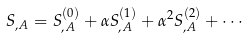Convert formula to latex. <formula><loc_0><loc_0><loc_500><loc_500>S _ { , A } = S _ { , A } ^ { ( 0 ) } + \alpha S _ { , A } ^ { ( 1 ) } + \alpha ^ { 2 } S _ { , A } ^ { ( 2 ) } + \cdots</formula> 